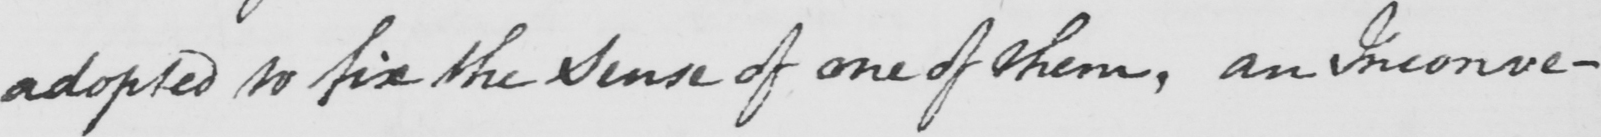What text is written in this handwritten line? adopted to fix the sense of one of them , an Inconvenience 